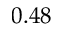Convert formula to latex. <formula><loc_0><loc_0><loc_500><loc_500>0 . 4 8</formula> 